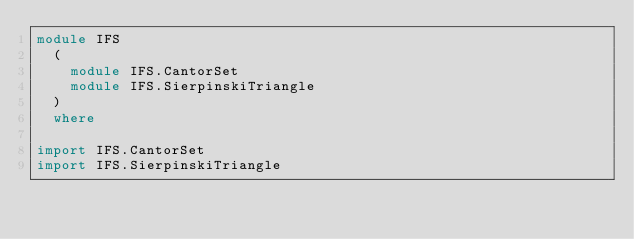Convert code to text. <code><loc_0><loc_0><loc_500><loc_500><_Haskell_>module IFS
  (
    module IFS.CantorSet
    module IFS.SierpinskiTriangle
  )
  where

import IFS.CantorSet
import IFS.SierpinskiTriangle
</code> 